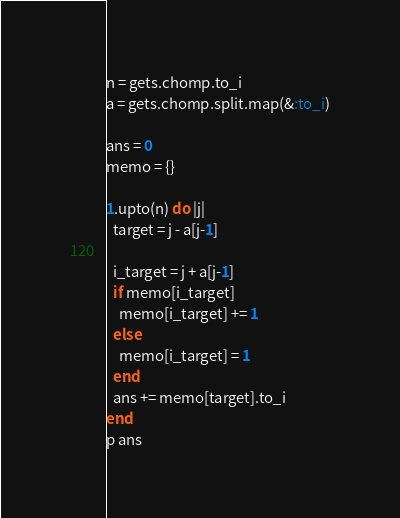<code> <loc_0><loc_0><loc_500><loc_500><_Ruby_>n = gets.chomp.to_i
a = gets.chomp.split.map(&:to_i)

ans = 0
memo = {}

1.upto(n) do |j|
  target = j - a[j-1]

  i_target = j + a[j-1]
  if memo[i_target]
    memo[i_target] += 1
  else
    memo[i_target] = 1
  end
  ans += memo[target].to_i
end
p ans
</code> 